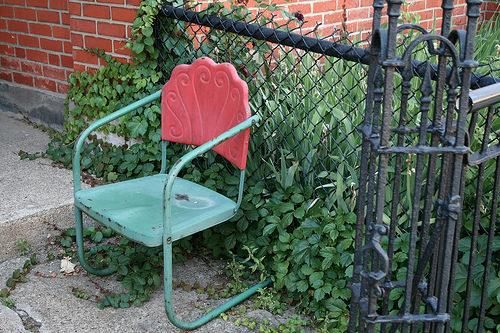<image>
Is the grass under the fence? Yes. The grass is positioned underneath the fence, with the fence above it in the vertical space. Where is the chair in relation to the fence? Is it behind the fence? No. The chair is not behind the fence. From this viewpoint, the chair appears to be positioned elsewhere in the scene. Is the chair to the right of the fence? No. The chair is not to the right of the fence. The horizontal positioning shows a different relationship. 